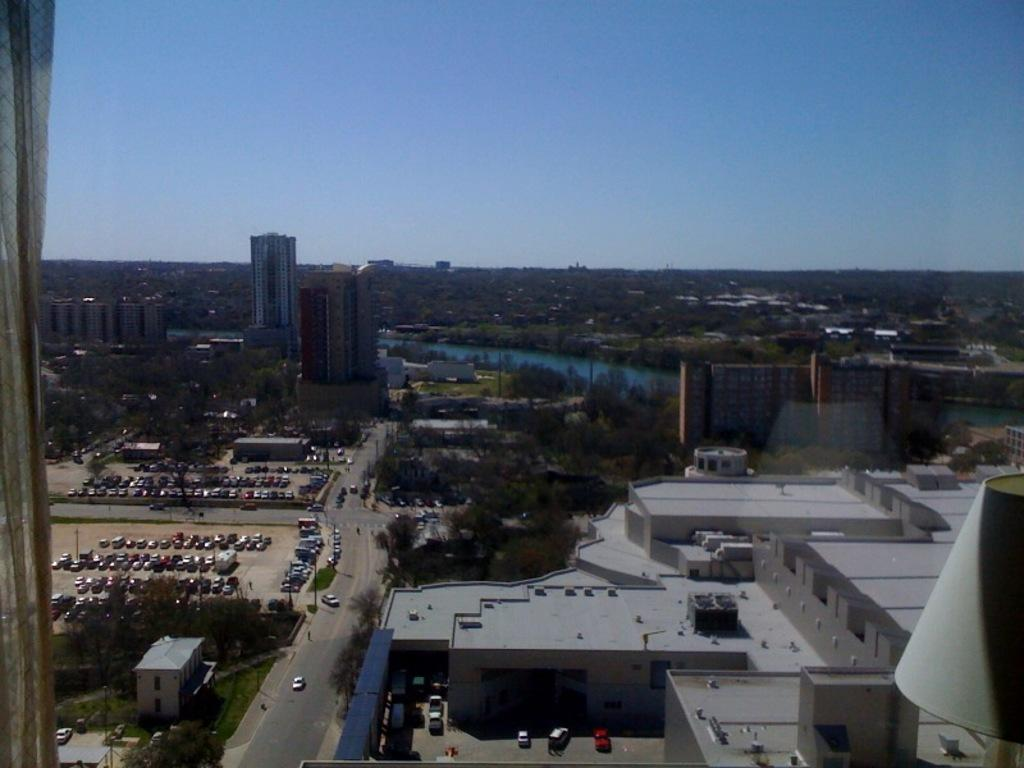What is located in the center of the image? There are buildings and cars in the center of the image. What type of infrastructure is present in the center of the image? There is a road in the center of the image. What type of vegetation can be seen in the image? Grass and trees are present in the image. What is the primary body of water visible in the image? There is water in the middle of the image. What is visible at the top of the image? The sky is visible at the top of the image. How many frogs are jumping on the buildings in the image? There are no frogs present in the image; it features buildings, cars, a road, grass, trees, water, and the sky. What type of society is depicted in the image? The image does not depict a specific society; it shows a scene with buildings, cars, a road, grass, trees, water, and the sky. 